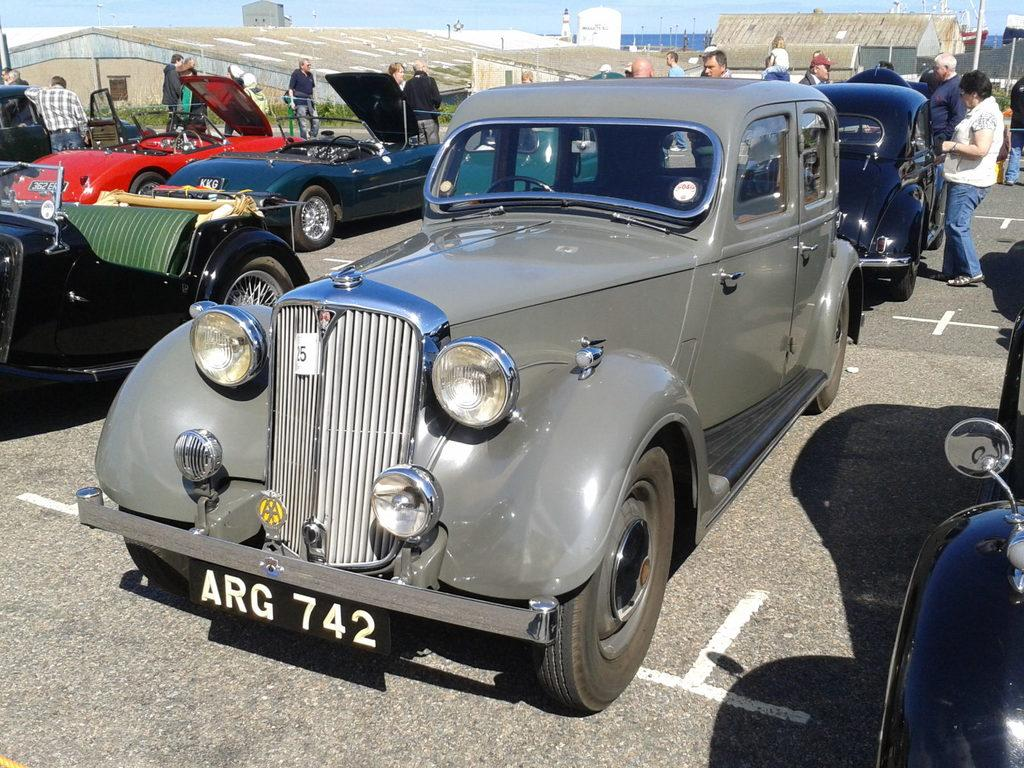What can be seen on the road in the image? There are vehicles on the road in the image. What else is visible in the image besides the vehicles? There is a group of people standing in the image, and there are houses present. What type of vegetation is in the image? Grass is present in the image. What can be seen in the background of the image? There are poles visible in the background. What company does the son of the person in the image work for? There is no person or son mentioned in the image, so it is not possible to answer this question. 